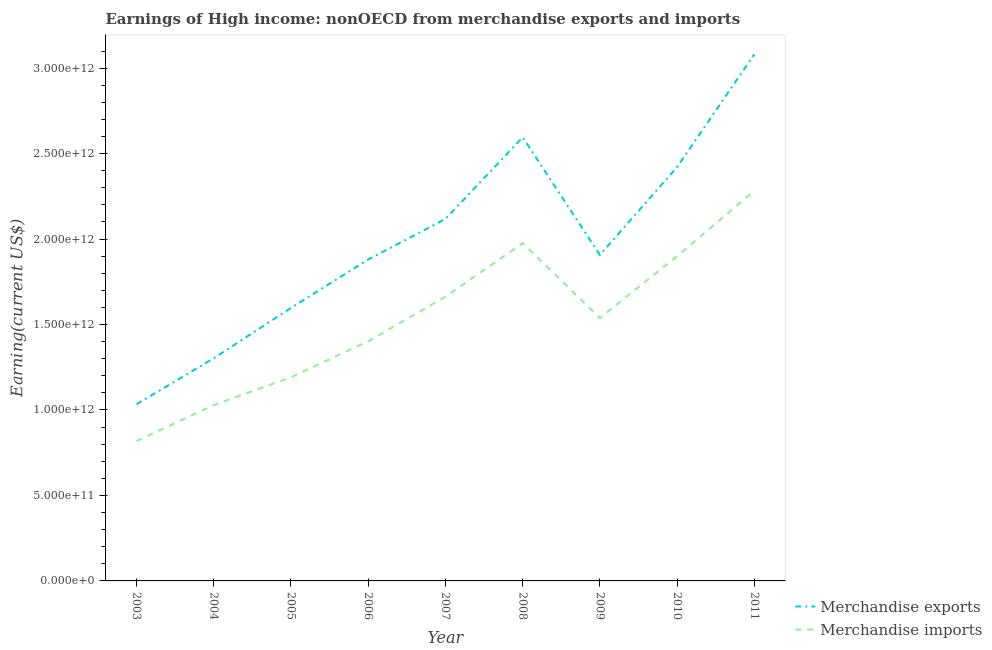How many different coloured lines are there?
Your answer should be very brief. 2. Is the number of lines equal to the number of legend labels?
Provide a short and direct response. Yes. What is the earnings from merchandise exports in 2006?
Provide a short and direct response. 1.88e+12. Across all years, what is the maximum earnings from merchandise exports?
Ensure brevity in your answer.  3.08e+12. Across all years, what is the minimum earnings from merchandise imports?
Your answer should be very brief. 8.18e+11. In which year was the earnings from merchandise imports minimum?
Give a very brief answer. 2003. What is the total earnings from merchandise exports in the graph?
Offer a terse response. 1.79e+13. What is the difference between the earnings from merchandise imports in 2010 and that in 2011?
Offer a very short reply. -3.83e+11. What is the difference between the earnings from merchandise imports in 2003 and the earnings from merchandise exports in 2005?
Your answer should be very brief. -7.79e+11. What is the average earnings from merchandise imports per year?
Offer a terse response. 1.53e+12. In the year 2006, what is the difference between the earnings from merchandise exports and earnings from merchandise imports?
Offer a terse response. 4.78e+11. In how many years, is the earnings from merchandise exports greater than 1400000000000 US$?
Keep it short and to the point. 7. What is the ratio of the earnings from merchandise imports in 2003 to that in 2008?
Your answer should be very brief. 0.41. Is the earnings from merchandise imports in 2009 less than that in 2010?
Your answer should be compact. Yes. What is the difference between the highest and the second highest earnings from merchandise imports?
Ensure brevity in your answer.  3.07e+11. What is the difference between the highest and the lowest earnings from merchandise imports?
Give a very brief answer. 1.47e+12. Is the sum of the earnings from merchandise exports in 2004 and 2011 greater than the maximum earnings from merchandise imports across all years?
Your response must be concise. Yes. Does the earnings from merchandise imports monotonically increase over the years?
Make the answer very short. No. Is the earnings from merchandise imports strictly greater than the earnings from merchandise exports over the years?
Your response must be concise. No. Is the earnings from merchandise imports strictly less than the earnings from merchandise exports over the years?
Offer a terse response. Yes. What is the difference between two consecutive major ticks on the Y-axis?
Make the answer very short. 5.00e+11. Does the graph contain grids?
Keep it short and to the point. No. What is the title of the graph?
Keep it short and to the point. Earnings of High income: nonOECD from merchandise exports and imports. What is the label or title of the Y-axis?
Your answer should be very brief. Earning(current US$). What is the Earning(current US$) of Merchandise exports in 2003?
Provide a succinct answer. 1.03e+12. What is the Earning(current US$) of Merchandise imports in 2003?
Your answer should be very brief. 8.18e+11. What is the Earning(current US$) of Merchandise exports in 2004?
Your answer should be very brief. 1.30e+12. What is the Earning(current US$) in Merchandise imports in 2004?
Keep it short and to the point. 1.03e+12. What is the Earning(current US$) of Merchandise exports in 2005?
Offer a very short reply. 1.60e+12. What is the Earning(current US$) in Merchandise imports in 2005?
Provide a short and direct response. 1.19e+12. What is the Earning(current US$) in Merchandise exports in 2006?
Keep it short and to the point. 1.88e+12. What is the Earning(current US$) of Merchandise imports in 2006?
Your answer should be very brief. 1.40e+12. What is the Earning(current US$) of Merchandise exports in 2007?
Make the answer very short. 2.12e+12. What is the Earning(current US$) in Merchandise imports in 2007?
Offer a terse response. 1.66e+12. What is the Earning(current US$) in Merchandise exports in 2008?
Your answer should be compact. 2.60e+12. What is the Earning(current US$) in Merchandise imports in 2008?
Provide a short and direct response. 1.98e+12. What is the Earning(current US$) in Merchandise exports in 2009?
Your response must be concise. 1.91e+12. What is the Earning(current US$) of Merchandise imports in 2009?
Your answer should be compact. 1.54e+12. What is the Earning(current US$) of Merchandise exports in 2010?
Your answer should be compact. 2.42e+12. What is the Earning(current US$) of Merchandise imports in 2010?
Provide a succinct answer. 1.90e+12. What is the Earning(current US$) in Merchandise exports in 2011?
Keep it short and to the point. 3.08e+12. What is the Earning(current US$) of Merchandise imports in 2011?
Your answer should be very brief. 2.28e+12. Across all years, what is the maximum Earning(current US$) in Merchandise exports?
Keep it short and to the point. 3.08e+12. Across all years, what is the maximum Earning(current US$) in Merchandise imports?
Make the answer very short. 2.28e+12. Across all years, what is the minimum Earning(current US$) of Merchandise exports?
Make the answer very short. 1.03e+12. Across all years, what is the minimum Earning(current US$) in Merchandise imports?
Your response must be concise. 8.18e+11. What is the total Earning(current US$) in Merchandise exports in the graph?
Provide a short and direct response. 1.79e+13. What is the total Earning(current US$) of Merchandise imports in the graph?
Your answer should be very brief. 1.38e+13. What is the difference between the Earning(current US$) in Merchandise exports in 2003 and that in 2004?
Your answer should be compact. -2.69e+11. What is the difference between the Earning(current US$) in Merchandise imports in 2003 and that in 2004?
Offer a terse response. -2.11e+11. What is the difference between the Earning(current US$) in Merchandise exports in 2003 and that in 2005?
Your answer should be very brief. -5.64e+11. What is the difference between the Earning(current US$) in Merchandise imports in 2003 and that in 2005?
Ensure brevity in your answer.  -3.73e+11. What is the difference between the Earning(current US$) in Merchandise exports in 2003 and that in 2006?
Provide a succinct answer. -8.47e+11. What is the difference between the Earning(current US$) of Merchandise imports in 2003 and that in 2006?
Offer a very short reply. -5.84e+11. What is the difference between the Earning(current US$) in Merchandise exports in 2003 and that in 2007?
Offer a terse response. -1.08e+12. What is the difference between the Earning(current US$) in Merchandise imports in 2003 and that in 2007?
Your response must be concise. -8.45e+11. What is the difference between the Earning(current US$) in Merchandise exports in 2003 and that in 2008?
Give a very brief answer. -1.56e+12. What is the difference between the Earning(current US$) in Merchandise imports in 2003 and that in 2008?
Your response must be concise. -1.16e+12. What is the difference between the Earning(current US$) of Merchandise exports in 2003 and that in 2009?
Keep it short and to the point. -8.74e+11. What is the difference between the Earning(current US$) of Merchandise imports in 2003 and that in 2009?
Provide a succinct answer. -7.20e+11. What is the difference between the Earning(current US$) of Merchandise exports in 2003 and that in 2010?
Ensure brevity in your answer.  -1.39e+12. What is the difference between the Earning(current US$) of Merchandise imports in 2003 and that in 2010?
Offer a very short reply. -1.08e+12. What is the difference between the Earning(current US$) of Merchandise exports in 2003 and that in 2011?
Your response must be concise. -2.05e+12. What is the difference between the Earning(current US$) of Merchandise imports in 2003 and that in 2011?
Your answer should be very brief. -1.47e+12. What is the difference between the Earning(current US$) of Merchandise exports in 2004 and that in 2005?
Provide a succinct answer. -2.95e+11. What is the difference between the Earning(current US$) in Merchandise imports in 2004 and that in 2005?
Your answer should be very brief. -1.62e+11. What is the difference between the Earning(current US$) of Merchandise exports in 2004 and that in 2006?
Give a very brief answer. -5.78e+11. What is the difference between the Earning(current US$) in Merchandise imports in 2004 and that in 2006?
Offer a very short reply. -3.73e+11. What is the difference between the Earning(current US$) in Merchandise exports in 2004 and that in 2007?
Make the answer very short. -8.15e+11. What is the difference between the Earning(current US$) in Merchandise imports in 2004 and that in 2007?
Your response must be concise. -6.34e+11. What is the difference between the Earning(current US$) of Merchandise exports in 2004 and that in 2008?
Your response must be concise. -1.29e+12. What is the difference between the Earning(current US$) of Merchandise imports in 2004 and that in 2008?
Your answer should be compact. -9.47e+11. What is the difference between the Earning(current US$) in Merchandise exports in 2004 and that in 2009?
Provide a short and direct response. -6.05e+11. What is the difference between the Earning(current US$) in Merchandise imports in 2004 and that in 2009?
Offer a terse response. -5.10e+11. What is the difference between the Earning(current US$) of Merchandise exports in 2004 and that in 2010?
Ensure brevity in your answer.  -1.12e+12. What is the difference between the Earning(current US$) in Merchandise imports in 2004 and that in 2010?
Ensure brevity in your answer.  -8.71e+11. What is the difference between the Earning(current US$) of Merchandise exports in 2004 and that in 2011?
Ensure brevity in your answer.  -1.78e+12. What is the difference between the Earning(current US$) in Merchandise imports in 2004 and that in 2011?
Provide a succinct answer. -1.25e+12. What is the difference between the Earning(current US$) of Merchandise exports in 2005 and that in 2006?
Your answer should be compact. -2.83e+11. What is the difference between the Earning(current US$) of Merchandise imports in 2005 and that in 2006?
Your answer should be compact. -2.11e+11. What is the difference between the Earning(current US$) of Merchandise exports in 2005 and that in 2007?
Your answer should be compact. -5.20e+11. What is the difference between the Earning(current US$) in Merchandise imports in 2005 and that in 2007?
Provide a short and direct response. -4.72e+11. What is the difference between the Earning(current US$) of Merchandise exports in 2005 and that in 2008?
Make the answer very short. -9.98e+11. What is the difference between the Earning(current US$) of Merchandise imports in 2005 and that in 2008?
Your response must be concise. -7.85e+11. What is the difference between the Earning(current US$) of Merchandise exports in 2005 and that in 2009?
Give a very brief answer. -3.10e+11. What is the difference between the Earning(current US$) of Merchandise imports in 2005 and that in 2009?
Your response must be concise. -3.47e+11. What is the difference between the Earning(current US$) of Merchandise exports in 2005 and that in 2010?
Keep it short and to the point. -8.24e+11. What is the difference between the Earning(current US$) of Merchandise imports in 2005 and that in 2010?
Provide a succinct answer. -7.09e+11. What is the difference between the Earning(current US$) of Merchandise exports in 2005 and that in 2011?
Your response must be concise. -1.48e+12. What is the difference between the Earning(current US$) of Merchandise imports in 2005 and that in 2011?
Your answer should be compact. -1.09e+12. What is the difference between the Earning(current US$) of Merchandise exports in 2006 and that in 2007?
Offer a very short reply. -2.37e+11. What is the difference between the Earning(current US$) in Merchandise imports in 2006 and that in 2007?
Provide a short and direct response. -2.61e+11. What is the difference between the Earning(current US$) of Merchandise exports in 2006 and that in 2008?
Offer a terse response. -7.15e+11. What is the difference between the Earning(current US$) in Merchandise imports in 2006 and that in 2008?
Make the answer very short. -5.74e+11. What is the difference between the Earning(current US$) in Merchandise exports in 2006 and that in 2009?
Provide a succinct answer. -2.71e+1. What is the difference between the Earning(current US$) of Merchandise imports in 2006 and that in 2009?
Your answer should be very brief. -1.36e+11. What is the difference between the Earning(current US$) of Merchandise exports in 2006 and that in 2010?
Provide a succinct answer. -5.41e+11. What is the difference between the Earning(current US$) of Merchandise imports in 2006 and that in 2010?
Provide a short and direct response. -4.98e+11. What is the difference between the Earning(current US$) of Merchandise exports in 2006 and that in 2011?
Make the answer very short. -1.20e+12. What is the difference between the Earning(current US$) in Merchandise imports in 2006 and that in 2011?
Offer a terse response. -8.81e+11. What is the difference between the Earning(current US$) of Merchandise exports in 2007 and that in 2008?
Make the answer very short. -4.78e+11. What is the difference between the Earning(current US$) in Merchandise imports in 2007 and that in 2008?
Your answer should be very brief. -3.13e+11. What is the difference between the Earning(current US$) in Merchandise exports in 2007 and that in 2009?
Your response must be concise. 2.10e+11. What is the difference between the Earning(current US$) of Merchandise imports in 2007 and that in 2009?
Provide a short and direct response. 1.25e+11. What is the difference between the Earning(current US$) in Merchandise exports in 2007 and that in 2010?
Give a very brief answer. -3.04e+11. What is the difference between the Earning(current US$) of Merchandise imports in 2007 and that in 2010?
Make the answer very short. -2.37e+11. What is the difference between the Earning(current US$) in Merchandise exports in 2007 and that in 2011?
Offer a terse response. -9.64e+11. What is the difference between the Earning(current US$) in Merchandise imports in 2007 and that in 2011?
Your answer should be compact. -6.20e+11. What is the difference between the Earning(current US$) of Merchandise exports in 2008 and that in 2009?
Provide a short and direct response. 6.88e+11. What is the difference between the Earning(current US$) of Merchandise imports in 2008 and that in 2009?
Ensure brevity in your answer.  4.38e+11. What is the difference between the Earning(current US$) in Merchandise exports in 2008 and that in 2010?
Make the answer very short. 1.74e+11. What is the difference between the Earning(current US$) of Merchandise imports in 2008 and that in 2010?
Provide a succinct answer. 7.62e+1. What is the difference between the Earning(current US$) in Merchandise exports in 2008 and that in 2011?
Keep it short and to the point. -4.86e+11. What is the difference between the Earning(current US$) of Merchandise imports in 2008 and that in 2011?
Your answer should be compact. -3.07e+11. What is the difference between the Earning(current US$) in Merchandise exports in 2009 and that in 2010?
Your answer should be very brief. -5.14e+11. What is the difference between the Earning(current US$) of Merchandise imports in 2009 and that in 2010?
Your answer should be compact. -3.61e+11. What is the difference between the Earning(current US$) in Merchandise exports in 2009 and that in 2011?
Provide a short and direct response. -1.17e+12. What is the difference between the Earning(current US$) in Merchandise imports in 2009 and that in 2011?
Ensure brevity in your answer.  -7.45e+11. What is the difference between the Earning(current US$) of Merchandise exports in 2010 and that in 2011?
Provide a succinct answer. -6.60e+11. What is the difference between the Earning(current US$) in Merchandise imports in 2010 and that in 2011?
Your answer should be compact. -3.83e+11. What is the difference between the Earning(current US$) of Merchandise exports in 2003 and the Earning(current US$) of Merchandise imports in 2004?
Give a very brief answer. 4.37e+09. What is the difference between the Earning(current US$) of Merchandise exports in 2003 and the Earning(current US$) of Merchandise imports in 2005?
Make the answer very short. -1.58e+11. What is the difference between the Earning(current US$) in Merchandise exports in 2003 and the Earning(current US$) in Merchandise imports in 2006?
Your answer should be very brief. -3.69e+11. What is the difference between the Earning(current US$) of Merchandise exports in 2003 and the Earning(current US$) of Merchandise imports in 2007?
Offer a very short reply. -6.30e+11. What is the difference between the Earning(current US$) in Merchandise exports in 2003 and the Earning(current US$) in Merchandise imports in 2008?
Provide a succinct answer. -9.43e+11. What is the difference between the Earning(current US$) of Merchandise exports in 2003 and the Earning(current US$) of Merchandise imports in 2009?
Offer a terse response. -5.05e+11. What is the difference between the Earning(current US$) in Merchandise exports in 2003 and the Earning(current US$) in Merchandise imports in 2010?
Offer a very short reply. -8.67e+11. What is the difference between the Earning(current US$) in Merchandise exports in 2003 and the Earning(current US$) in Merchandise imports in 2011?
Your response must be concise. -1.25e+12. What is the difference between the Earning(current US$) in Merchandise exports in 2004 and the Earning(current US$) in Merchandise imports in 2005?
Offer a very short reply. 1.11e+11. What is the difference between the Earning(current US$) of Merchandise exports in 2004 and the Earning(current US$) of Merchandise imports in 2006?
Give a very brief answer. -9.98e+1. What is the difference between the Earning(current US$) of Merchandise exports in 2004 and the Earning(current US$) of Merchandise imports in 2007?
Offer a very short reply. -3.61e+11. What is the difference between the Earning(current US$) in Merchandise exports in 2004 and the Earning(current US$) in Merchandise imports in 2008?
Your answer should be compact. -6.74e+11. What is the difference between the Earning(current US$) of Merchandise exports in 2004 and the Earning(current US$) of Merchandise imports in 2009?
Make the answer very short. -2.36e+11. What is the difference between the Earning(current US$) in Merchandise exports in 2004 and the Earning(current US$) in Merchandise imports in 2010?
Make the answer very short. -5.98e+11. What is the difference between the Earning(current US$) of Merchandise exports in 2004 and the Earning(current US$) of Merchandise imports in 2011?
Your answer should be very brief. -9.81e+11. What is the difference between the Earning(current US$) in Merchandise exports in 2005 and the Earning(current US$) in Merchandise imports in 2006?
Your answer should be compact. 1.95e+11. What is the difference between the Earning(current US$) in Merchandise exports in 2005 and the Earning(current US$) in Merchandise imports in 2007?
Your answer should be compact. -6.59e+1. What is the difference between the Earning(current US$) of Merchandise exports in 2005 and the Earning(current US$) of Merchandise imports in 2008?
Your response must be concise. -3.79e+11. What is the difference between the Earning(current US$) of Merchandise exports in 2005 and the Earning(current US$) of Merchandise imports in 2009?
Your answer should be very brief. 5.86e+1. What is the difference between the Earning(current US$) in Merchandise exports in 2005 and the Earning(current US$) in Merchandise imports in 2010?
Ensure brevity in your answer.  -3.03e+11. What is the difference between the Earning(current US$) of Merchandise exports in 2005 and the Earning(current US$) of Merchandise imports in 2011?
Offer a terse response. -6.86e+11. What is the difference between the Earning(current US$) of Merchandise exports in 2006 and the Earning(current US$) of Merchandise imports in 2007?
Give a very brief answer. 2.17e+11. What is the difference between the Earning(current US$) in Merchandise exports in 2006 and the Earning(current US$) in Merchandise imports in 2008?
Make the answer very short. -9.57e+1. What is the difference between the Earning(current US$) in Merchandise exports in 2006 and the Earning(current US$) in Merchandise imports in 2009?
Ensure brevity in your answer.  3.42e+11. What is the difference between the Earning(current US$) in Merchandise exports in 2006 and the Earning(current US$) in Merchandise imports in 2010?
Ensure brevity in your answer.  -1.95e+1. What is the difference between the Earning(current US$) of Merchandise exports in 2006 and the Earning(current US$) of Merchandise imports in 2011?
Ensure brevity in your answer.  -4.03e+11. What is the difference between the Earning(current US$) of Merchandise exports in 2007 and the Earning(current US$) of Merchandise imports in 2008?
Give a very brief answer. 1.42e+11. What is the difference between the Earning(current US$) of Merchandise exports in 2007 and the Earning(current US$) of Merchandise imports in 2009?
Make the answer very short. 5.79e+11. What is the difference between the Earning(current US$) of Merchandise exports in 2007 and the Earning(current US$) of Merchandise imports in 2010?
Ensure brevity in your answer.  2.18e+11. What is the difference between the Earning(current US$) in Merchandise exports in 2007 and the Earning(current US$) in Merchandise imports in 2011?
Offer a very short reply. -1.66e+11. What is the difference between the Earning(current US$) in Merchandise exports in 2008 and the Earning(current US$) in Merchandise imports in 2009?
Offer a terse response. 1.06e+12. What is the difference between the Earning(current US$) in Merchandise exports in 2008 and the Earning(current US$) in Merchandise imports in 2010?
Offer a terse response. 6.96e+11. What is the difference between the Earning(current US$) of Merchandise exports in 2008 and the Earning(current US$) of Merchandise imports in 2011?
Ensure brevity in your answer.  3.12e+11. What is the difference between the Earning(current US$) in Merchandise exports in 2009 and the Earning(current US$) in Merchandise imports in 2010?
Give a very brief answer. 7.63e+09. What is the difference between the Earning(current US$) of Merchandise exports in 2009 and the Earning(current US$) of Merchandise imports in 2011?
Your answer should be compact. -3.76e+11. What is the difference between the Earning(current US$) of Merchandise exports in 2010 and the Earning(current US$) of Merchandise imports in 2011?
Ensure brevity in your answer.  1.38e+11. What is the average Earning(current US$) in Merchandise exports per year?
Keep it short and to the point. 1.99e+12. What is the average Earning(current US$) in Merchandise imports per year?
Provide a short and direct response. 1.53e+12. In the year 2003, what is the difference between the Earning(current US$) of Merchandise exports and Earning(current US$) of Merchandise imports?
Your response must be concise. 2.15e+11. In the year 2004, what is the difference between the Earning(current US$) of Merchandise exports and Earning(current US$) of Merchandise imports?
Provide a succinct answer. 2.73e+11. In the year 2005, what is the difference between the Earning(current US$) of Merchandise exports and Earning(current US$) of Merchandise imports?
Give a very brief answer. 4.06e+11. In the year 2006, what is the difference between the Earning(current US$) in Merchandise exports and Earning(current US$) in Merchandise imports?
Offer a terse response. 4.78e+11. In the year 2007, what is the difference between the Earning(current US$) of Merchandise exports and Earning(current US$) of Merchandise imports?
Provide a succinct answer. 4.55e+11. In the year 2008, what is the difference between the Earning(current US$) in Merchandise exports and Earning(current US$) in Merchandise imports?
Offer a very short reply. 6.19e+11. In the year 2009, what is the difference between the Earning(current US$) in Merchandise exports and Earning(current US$) in Merchandise imports?
Your answer should be compact. 3.69e+11. In the year 2010, what is the difference between the Earning(current US$) in Merchandise exports and Earning(current US$) in Merchandise imports?
Offer a very short reply. 5.22e+11. In the year 2011, what is the difference between the Earning(current US$) in Merchandise exports and Earning(current US$) in Merchandise imports?
Make the answer very short. 7.98e+11. What is the ratio of the Earning(current US$) of Merchandise exports in 2003 to that in 2004?
Keep it short and to the point. 0.79. What is the ratio of the Earning(current US$) of Merchandise imports in 2003 to that in 2004?
Your response must be concise. 0.8. What is the ratio of the Earning(current US$) in Merchandise exports in 2003 to that in 2005?
Offer a very short reply. 0.65. What is the ratio of the Earning(current US$) of Merchandise imports in 2003 to that in 2005?
Give a very brief answer. 0.69. What is the ratio of the Earning(current US$) in Merchandise exports in 2003 to that in 2006?
Offer a terse response. 0.55. What is the ratio of the Earning(current US$) in Merchandise imports in 2003 to that in 2006?
Keep it short and to the point. 0.58. What is the ratio of the Earning(current US$) of Merchandise exports in 2003 to that in 2007?
Provide a short and direct response. 0.49. What is the ratio of the Earning(current US$) in Merchandise imports in 2003 to that in 2007?
Give a very brief answer. 0.49. What is the ratio of the Earning(current US$) of Merchandise exports in 2003 to that in 2008?
Provide a succinct answer. 0.4. What is the ratio of the Earning(current US$) of Merchandise imports in 2003 to that in 2008?
Your answer should be compact. 0.41. What is the ratio of the Earning(current US$) in Merchandise exports in 2003 to that in 2009?
Your response must be concise. 0.54. What is the ratio of the Earning(current US$) in Merchandise imports in 2003 to that in 2009?
Your response must be concise. 0.53. What is the ratio of the Earning(current US$) in Merchandise exports in 2003 to that in 2010?
Make the answer very short. 0.43. What is the ratio of the Earning(current US$) in Merchandise imports in 2003 to that in 2010?
Your response must be concise. 0.43. What is the ratio of the Earning(current US$) of Merchandise exports in 2003 to that in 2011?
Make the answer very short. 0.34. What is the ratio of the Earning(current US$) in Merchandise imports in 2003 to that in 2011?
Your answer should be very brief. 0.36. What is the ratio of the Earning(current US$) in Merchandise exports in 2004 to that in 2005?
Your answer should be compact. 0.82. What is the ratio of the Earning(current US$) in Merchandise imports in 2004 to that in 2005?
Offer a terse response. 0.86. What is the ratio of the Earning(current US$) in Merchandise exports in 2004 to that in 2006?
Ensure brevity in your answer.  0.69. What is the ratio of the Earning(current US$) of Merchandise imports in 2004 to that in 2006?
Offer a very short reply. 0.73. What is the ratio of the Earning(current US$) of Merchandise exports in 2004 to that in 2007?
Ensure brevity in your answer.  0.61. What is the ratio of the Earning(current US$) of Merchandise imports in 2004 to that in 2007?
Your response must be concise. 0.62. What is the ratio of the Earning(current US$) in Merchandise exports in 2004 to that in 2008?
Your answer should be very brief. 0.5. What is the ratio of the Earning(current US$) in Merchandise imports in 2004 to that in 2008?
Provide a short and direct response. 0.52. What is the ratio of the Earning(current US$) of Merchandise exports in 2004 to that in 2009?
Provide a succinct answer. 0.68. What is the ratio of the Earning(current US$) of Merchandise imports in 2004 to that in 2009?
Provide a succinct answer. 0.67. What is the ratio of the Earning(current US$) of Merchandise exports in 2004 to that in 2010?
Your answer should be compact. 0.54. What is the ratio of the Earning(current US$) in Merchandise imports in 2004 to that in 2010?
Provide a succinct answer. 0.54. What is the ratio of the Earning(current US$) in Merchandise exports in 2004 to that in 2011?
Offer a very short reply. 0.42. What is the ratio of the Earning(current US$) of Merchandise imports in 2004 to that in 2011?
Your answer should be very brief. 0.45. What is the ratio of the Earning(current US$) in Merchandise exports in 2005 to that in 2006?
Your answer should be very brief. 0.85. What is the ratio of the Earning(current US$) in Merchandise imports in 2005 to that in 2006?
Your answer should be very brief. 0.85. What is the ratio of the Earning(current US$) of Merchandise exports in 2005 to that in 2007?
Provide a short and direct response. 0.75. What is the ratio of the Earning(current US$) in Merchandise imports in 2005 to that in 2007?
Provide a succinct answer. 0.72. What is the ratio of the Earning(current US$) in Merchandise exports in 2005 to that in 2008?
Keep it short and to the point. 0.62. What is the ratio of the Earning(current US$) in Merchandise imports in 2005 to that in 2008?
Keep it short and to the point. 0.6. What is the ratio of the Earning(current US$) in Merchandise exports in 2005 to that in 2009?
Offer a terse response. 0.84. What is the ratio of the Earning(current US$) in Merchandise imports in 2005 to that in 2009?
Provide a short and direct response. 0.77. What is the ratio of the Earning(current US$) of Merchandise exports in 2005 to that in 2010?
Make the answer very short. 0.66. What is the ratio of the Earning(current US$) of Merchandise imports in 2005 to that in 2010?
Provide a succinct answer. 0.63. What is the ratio of the Earning(current US$) of Merchandise exports in 2005 to that in 2011?
Give a very brief answer. 0.52. What is the ratio of the Earning(current US$) of Merchandise imports in 2005 to that in 2011?
Make the answer very short. 0.52. What is the ratio of the Earning(current US$) of Merchandise exports in 2006 to that in 2007?
Offer a terse response. 0.89. What is the ratio of the Earning(current US$) of Merchandise imports in 2006 to that in 2007?
Your answer should be very brief. 0.84. What is the ratio of the Earning(current US$) in Merchandise exports in 2006 to that in 2008?
Offer a terse response. 0.72. What is the ratio of the Earning(current US$) of Merchandise imports in 2006 to that in 2008?
Offer a terse response. 0.71. What is the ratio of the Earning(current US$) of Merchandise exports in 2006 to that in 2009?
Make the answer very short. 0.99. What is the ratio of the Earning(current US$) in Merchandise imports in 2006 to that in 2009?
Make the answer very short. 0.91. What is the ratio of the Earning(current US$) of Merchandise exports in 2006 to that in 2010?
Keep it short and to the point. 0.78. What is the ratio of the Earning(current US$) in Merchandise imports in 2006 to that in 2010?
Your answer should be compact. 0.74. What is the ratio of the Earning(current US$) in Merchandise exports in 2006 to that in 2011?
Provide a succinct answer. 0.61. What is the ratio of the Earning(current US$) in Merchandise imports in 2006 to that in 2011?
Your answer should be very brief. 0.61. What is the ratio of the Earning(current US$) in Merchandise exports in 2007 to that in 2008?
Your answer should be compact. 0.82. What is the ratio of the Earning(current US$) in Merchandise imports in 2007 to that in 2008?
Offer a terse response. 0.84. What is the ratio of the Earning(current US$) of Merchandise exports in 2007 to that in 2009?
Offer a very short reply. 1.11. What is the ratio of the Earning(current US$) of Merchandise imports in 2007 to that in 2009?
Your response must be concise. 1.08. What is the ratio of the Earning(current US$) of Merchandise exports in 2007 to that in 2010?
Ensure brevity in your answer.  0.87. What is the ratio of the Earning(current US$) in Merchandise imports in 2007 to that in 2010?
Your response must be concise. 0.88. What is the ratio of the Earning(current US$) in Merchandise exports in 2007 to that in 2011?
Provide a short and direct response. 0.69. What is the ratio of the Earning(current US$) of Merchandise imports in 2007 to that in 2011?
Your answer should be compact. 0.73. What is the ratio of the Earning(current US$) in Merchandise exports in 2008 to that in 2009?
Provide a short and direct response. 1.36. What is the ratio of the Earning(current US$) of Merchandise imports in 2008 to that in 2009?
Ensure brevity in your answer.  1.28. What is the ratio of the Earning(current US$) in Merchandise exports in 2008 to that in 2010?
Give a very brief answer. 1.07. What is the ratio of the Earning(current US$) in Merchandise imports in 2008 to that in 2010?
Your answer should be very brief. 1.04. What is the ratio of the Earning(current US$) in Merchandise exports in 2008 to that in 2011?
Make the answer very short. 0.84. What is the ratio of the Earning(current US$) in Merchandise imports in 2008 to that in 2011?
Your answer should be compact. 0.87. What is the ratio of the Earning(current US$) in Merchandise exports in 2009 to that in 2010?
Your response must be concise. 0.79. What is the ratio of the Earning(current US$) of Merchandise imports in 2009 to that in 2010?
Keep it short and to the point. 0.81. What is the ratio of the Earning(current US$) of Merchandise exports in 2009 to that in 2011?
Your answer should be compact. 0.62. What is the ratio of the Earning(current US$) in Merchandise imports in 2009 to that in 2011?
Provide a short and direct response. 0.67. What is the ratio of the Earning(current US$) in Merchandise exports in 2010 to that in 2011?
Provide a short and direct response. 0.79. What is the ratio of the Earning(current US$) of Merchandise imports in 2010 to that in 2011?
Your answer should be very brief. 0.83. What is the difference between the highest and the second highest Earning(current US$) in Merchandise exports?
Ensure brevity in your answer.  4.86e+11. What is the difference between the highest and the second highest Earning(current US$) in Merchandise imports?
Your response must be concise. 3.07e+11. What is the difference between the highest and the lowest Earning(current US$) in Merchandise exports?
Give a very brief answer. 2.05e+12. What is the difference between the highest and the lowest Earning(current US$) in Merchandise imports?
Offer a very short reply. 1.47e+12. 